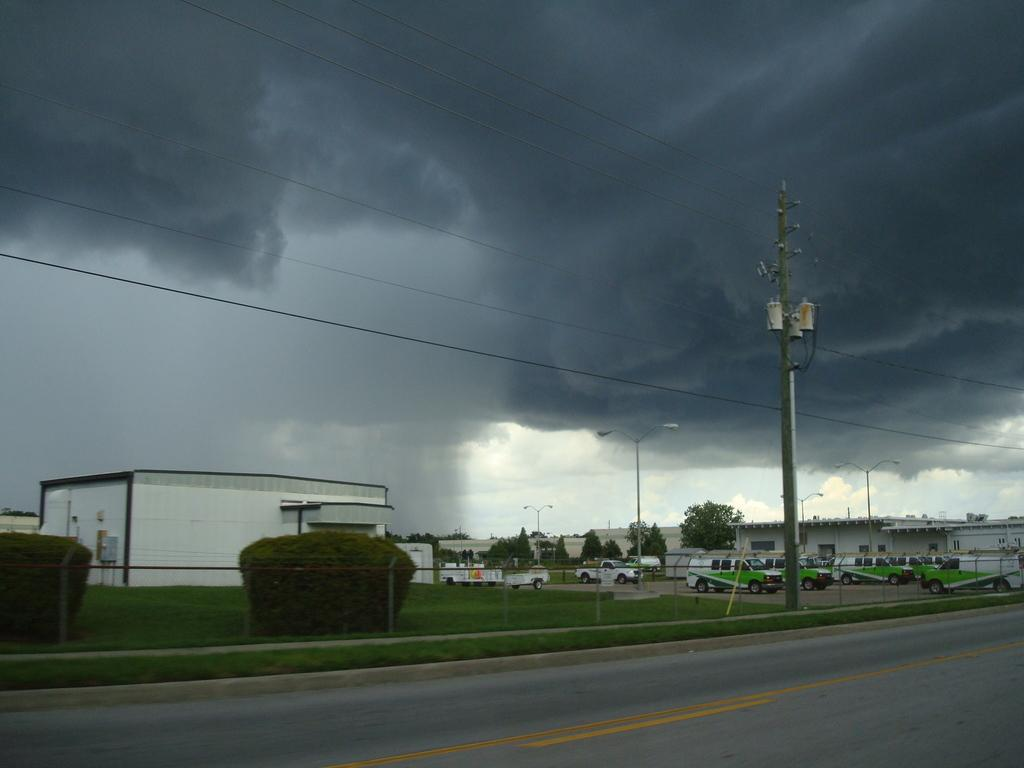What is one of the main features of the image? There is a road in the image. What is attached to the road in the image? There is a current pole in the image, and wires are visible. What type of barrier is present in the image? There is a fence in the image. What type of vegetation can be seen in the image? Shrubs and grass are visible in the image, as well as trees. What type of structures are visible in the image? Houses are visible in the image, along with light poles. What is the condition of the sky in the background of the image? The sky in the background is cloudy. Where is the cobweb located in the image? There is no cobweb present in the image. What type of surprise can be seen happening in the image? There is no surprise depicted in the image; it shows a typical scene with a road, current pole, fence, vegetation, structures, and sky. 